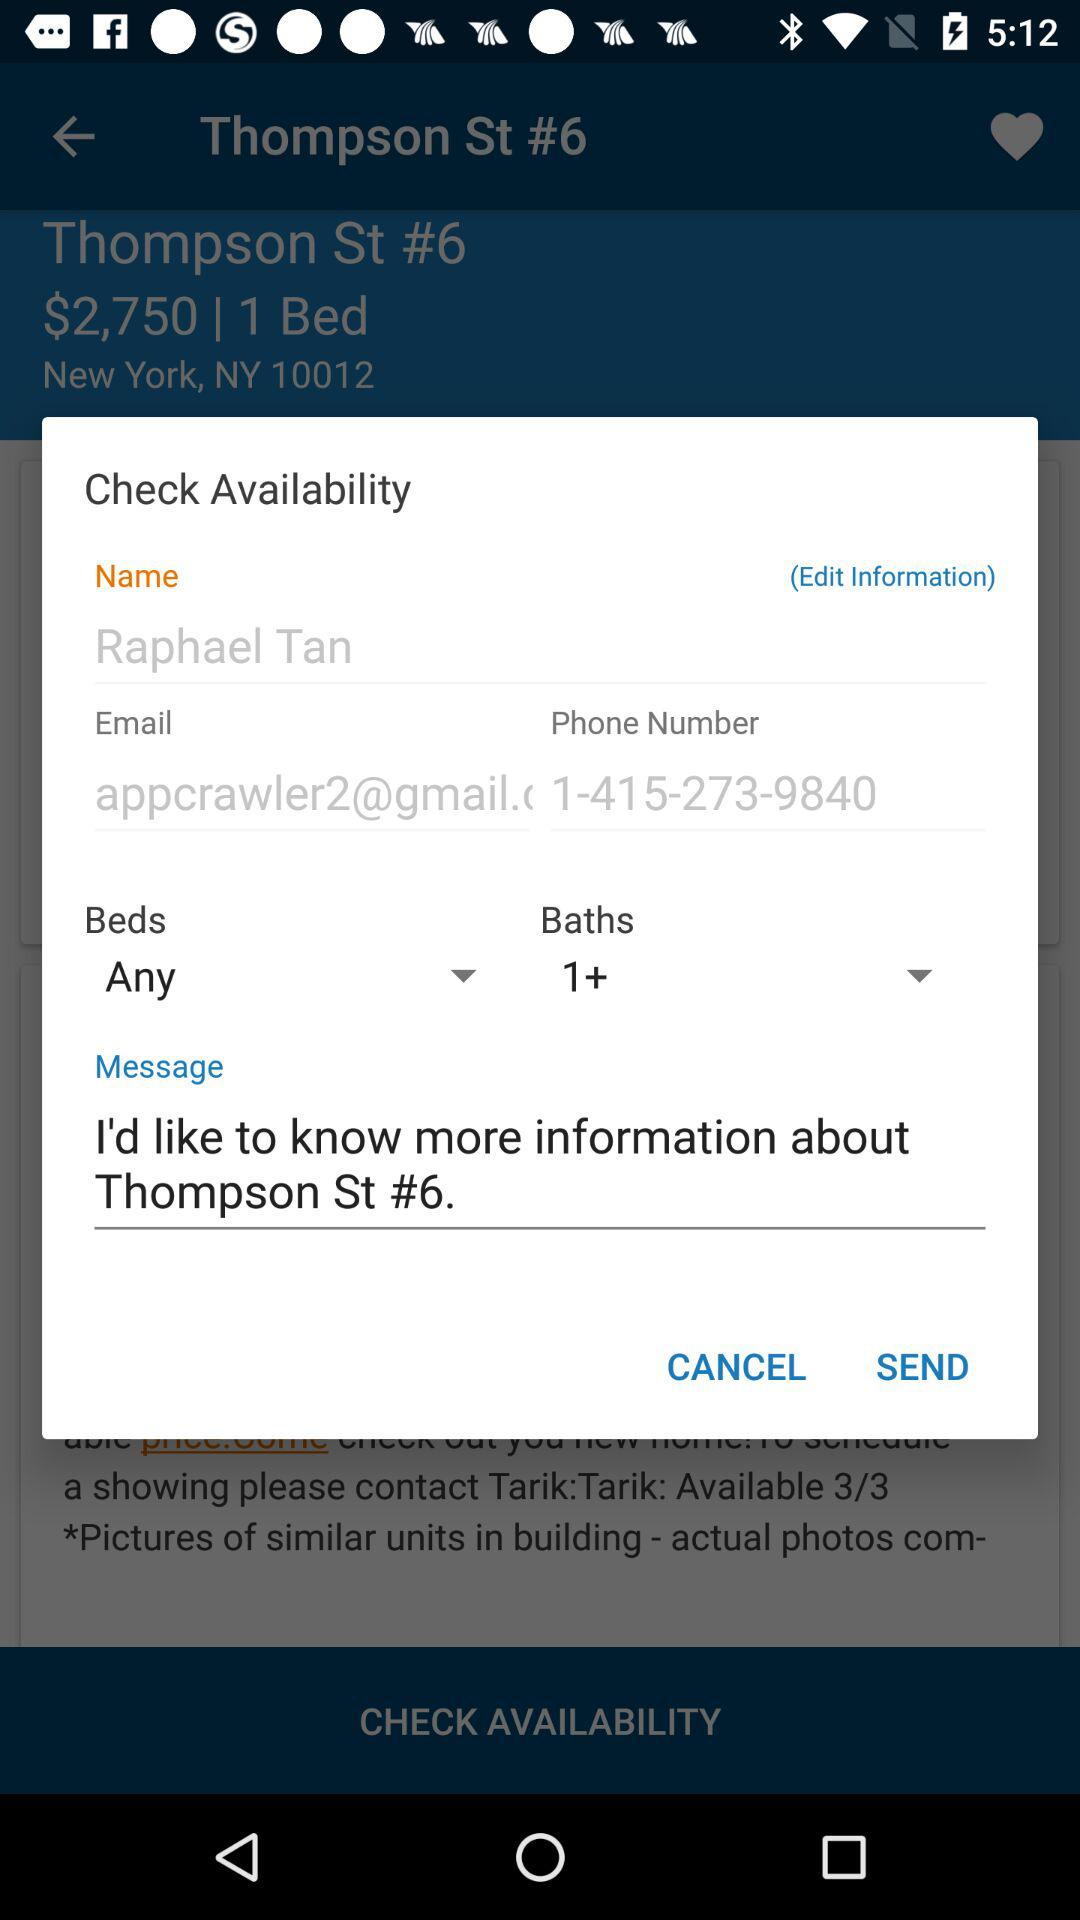What is the phone number? The phone number is 1-415-273-9840. 